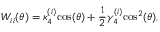<formula> <loc_0><loc_0><loc_500><loc_500>W _ { i i } ( \theta ) = \kappa _ { 4 } ^ { ( i ) } \cos ( \theta ) + \frac { 1 } { 2 } \gamma _ { 4 } ^ { ( i ) } \cos ^ { 2 } ( \theta ) ,</formula> 